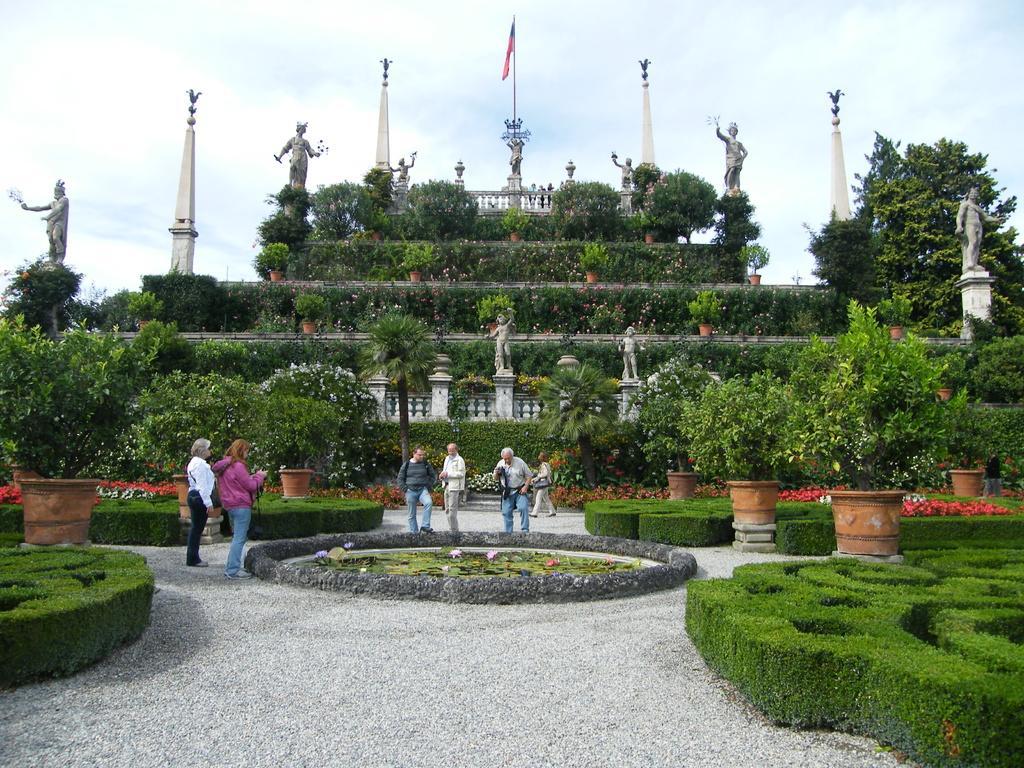How would you summarize this image in a sentence or two? In the center of the image there are plants,statues. There is a flag. At the bottom of the image there are stones. There are people standing. At the top of the image there is sky. 